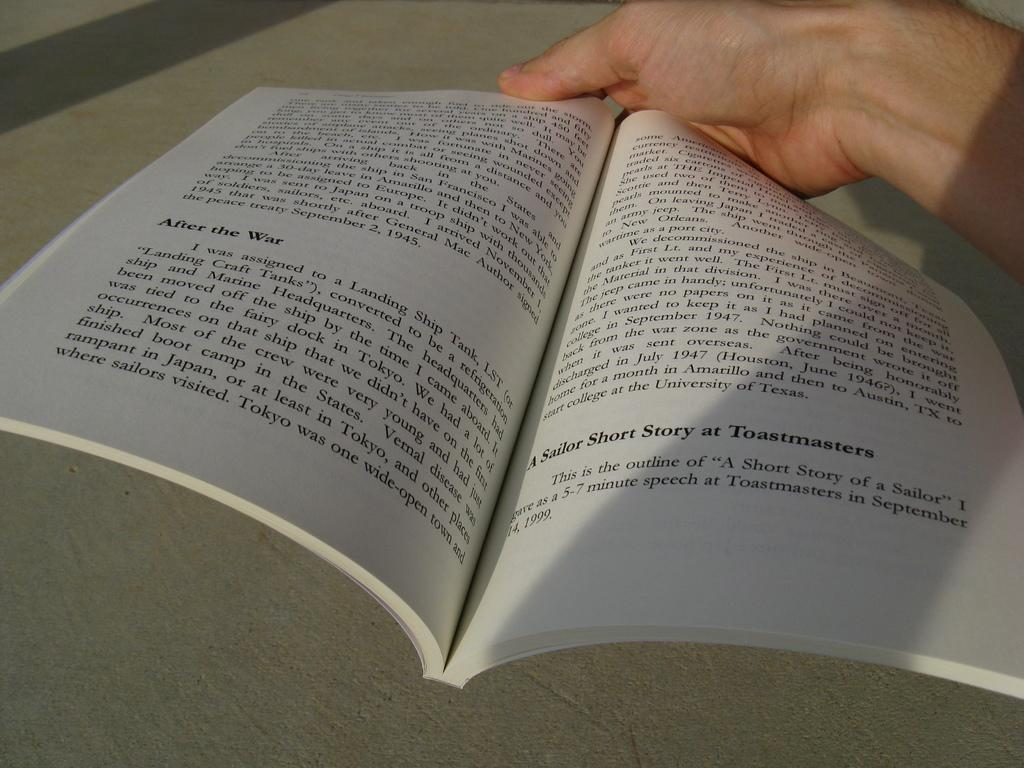<image>
Summarize the visual content of the image. A book with a paragraph that is titled A similar Short Story at Toastmasters. 